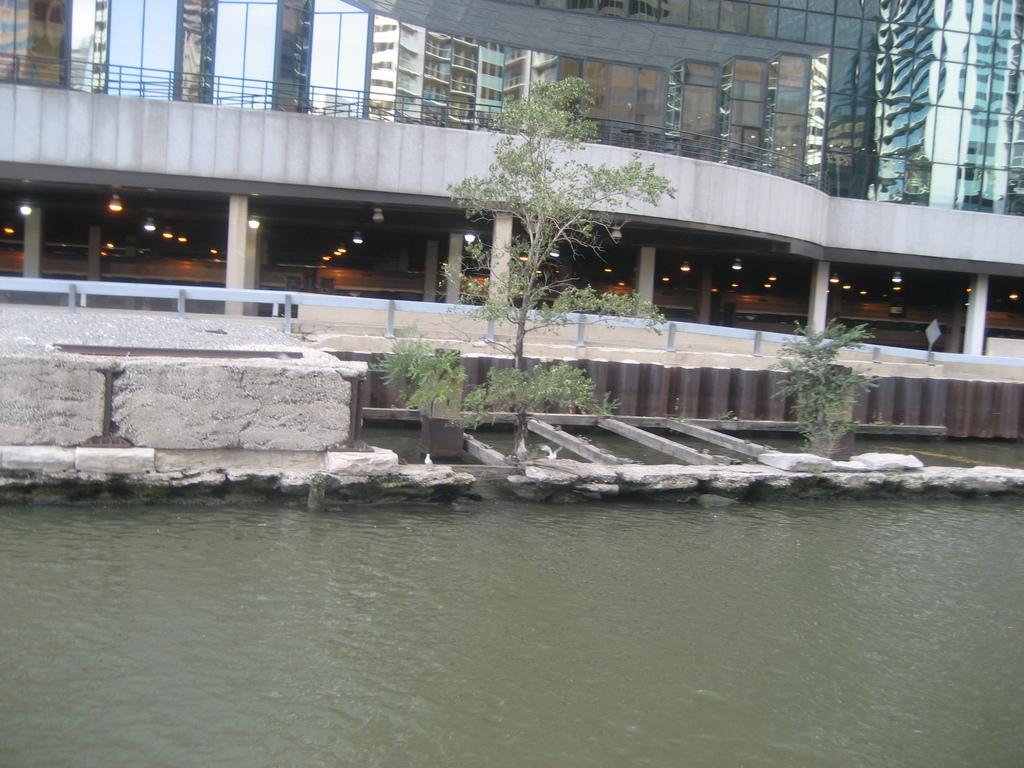What is visible in the image? Water and buildings are visible in the image. Can you describe the water in the image? The water is visible, but its specific characteristics are not mentioned in the facts. What type of structures are depicted in the image? There are buildings in the image. What is the mind doing in the image? There is no mention of a mind in the image; it only features water and buildings. How many holes can be seen in the image? There is no mention of any holes in the image. 